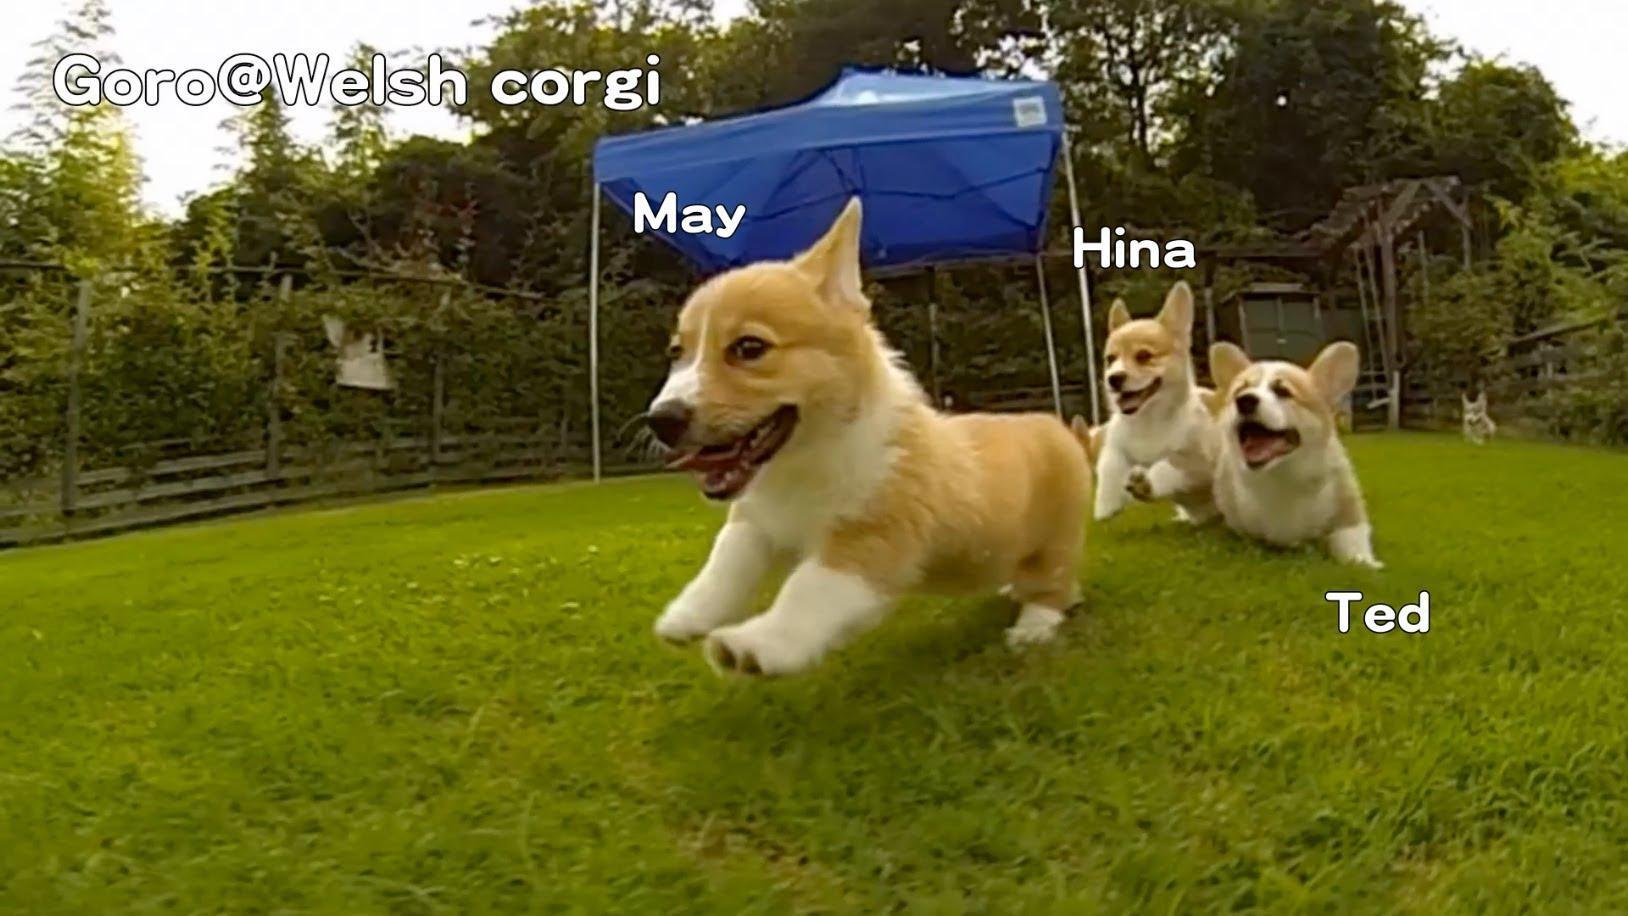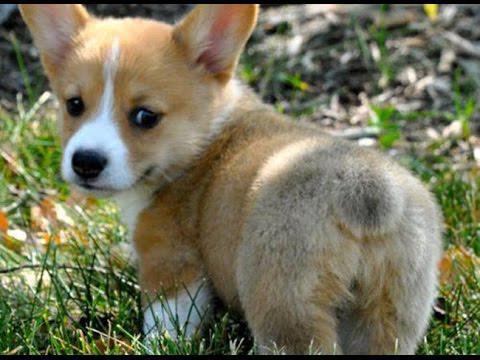The first image is the image on the left, the second image is the image on the right. Given the left and right images, does the statement "One image shows three corgi dogs running across the grass, with one dog in the lead, and a blue tent canopy behind them." hold true? Answer yes or no. Yes. The first image is the image on the left, the second image is the image on the right. Analyze the images presented: Is the assertion "At least one puppy has both front paws off the ground." valid? Answer yes or no. Yes. 